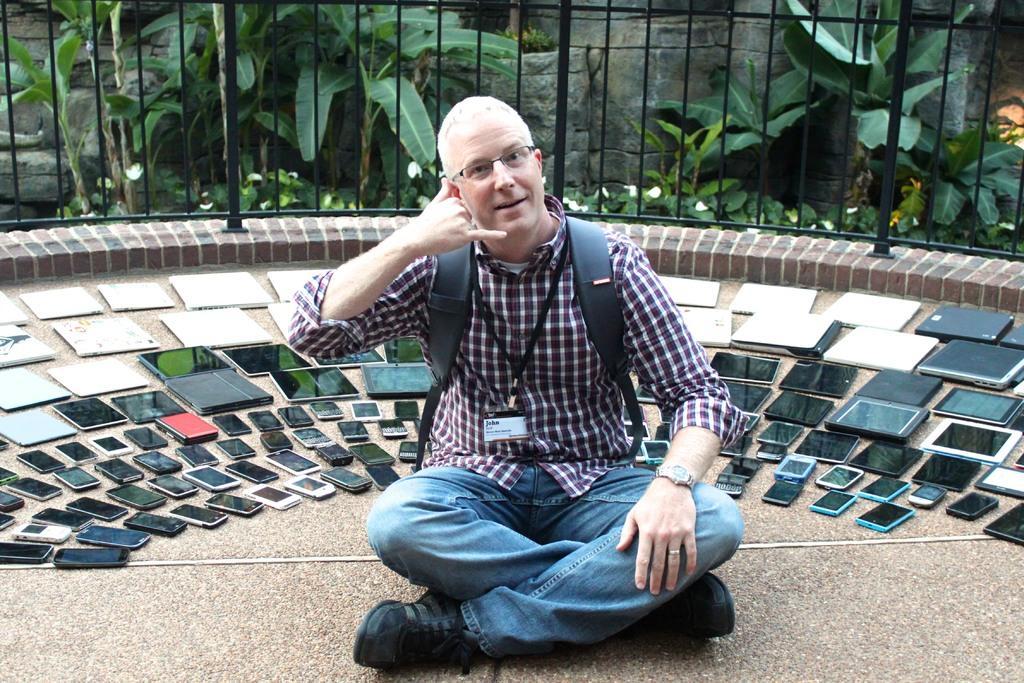Could you give a brief overview of what you see in this image? In this picture we can see a man sitting here, he is carrying a backpack, we can see some mobile phones and tabs here, in the background we can see trees, we can see an identity card here. 